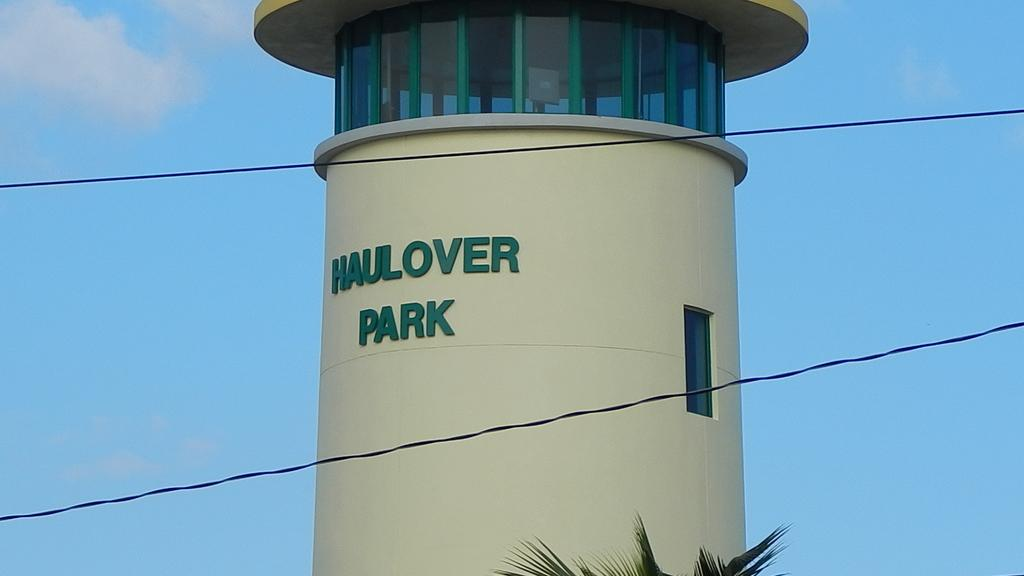What type of structure is in the picture? There is a building in the picture. What feature can be seen on the building? The building has a glass window. What is visible on the glass window? There is something written on the glass window. What type of vegetation is in the picture? There is a tree in the picture. How would you describe the sky in the image? The sky is clear in the image. What type of pleasure can be seen enjoying a turkey in the image? There is no pleasure or turkey present in the image; it features a building with a glass window and a tree. What type of destruction is visible in the image? There is no destruction present in the image; it is a peaceful scene with a building, a tree, and a clear sky. 